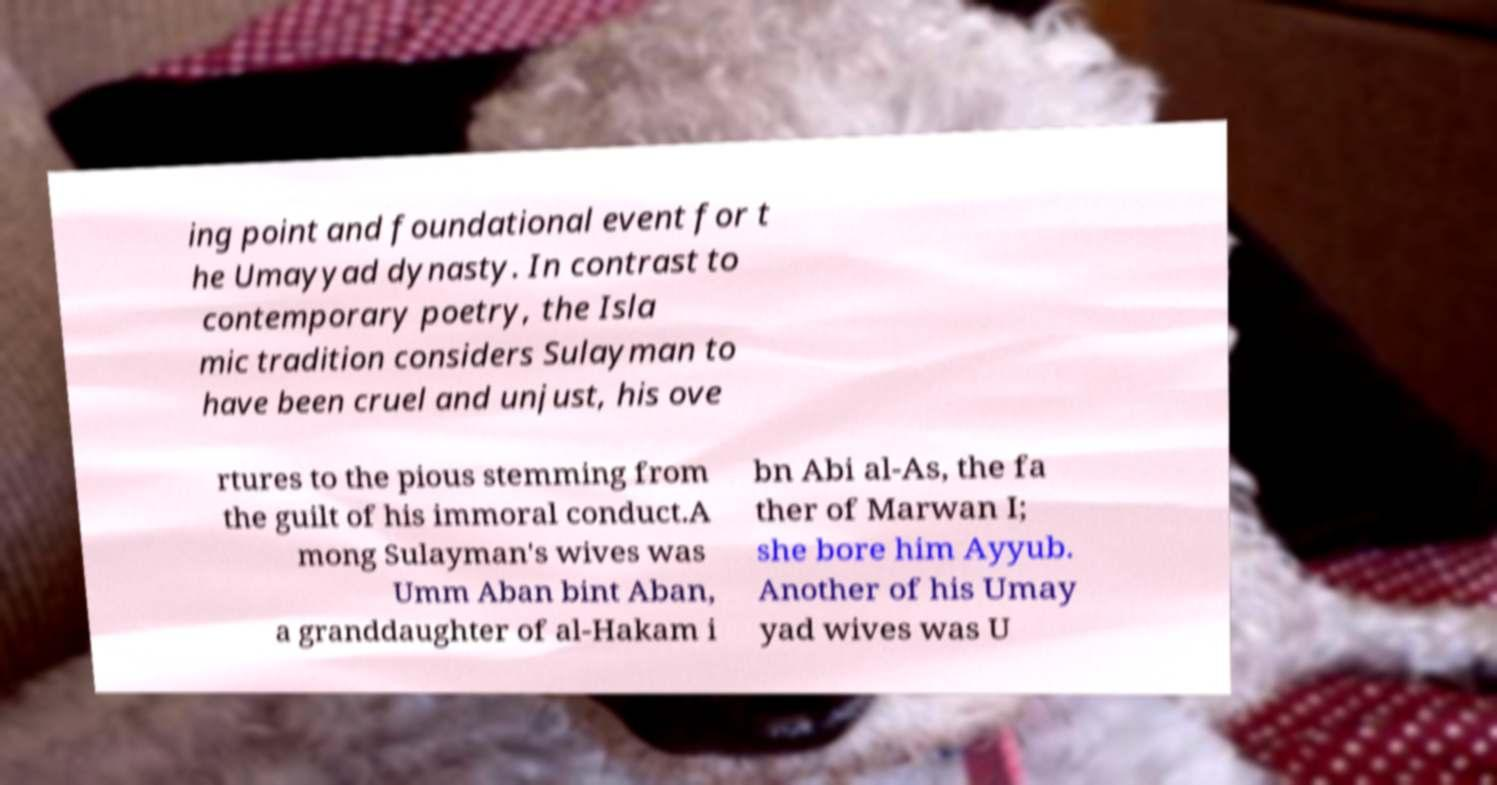Could you extract and type out the text from this image? ing point and foundational event for t he Umayyad dynasty. In contrast to contemporary poetry, the Isla mic tradition considers Sulayman to have been cruel and unjust, his ove rtures to the pious stemming from the guilt of his immoral conduct.A mong Sulayman's wives was Umm Aban bint Aban, a granddaughter of al-Hakam i bn Abi al-As, the fa ther of Marwan I; she bore him Ayyub. Another of his Umay yad wives was U 